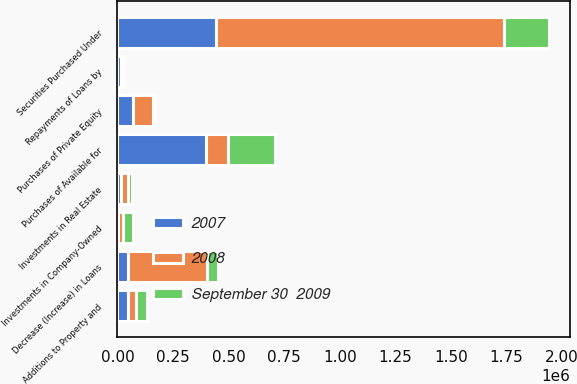Convert chart to OTSL. <chart><loc_0><loc_0><loc_500><loc_500><stacked_bar_chart><ecel><fcel>Additions to Property and<fcel>Decrease (Increase) in Loans<fcel>Purchases of Private Equity<fcel>Investments in Company-Owned<fcel>Investments in Real Estate<fcel>Repayments of Loans by<fcel>Securities Purchased Under<fcel>Purchases of Available for<nl><fcel>2008<fcel>35539<fcel>357054<fcel>88780<fcel>22793<fcel>30425<fcel>1829<fcel>1.295e+06<fcel>102516<nl><fcel>September 30  2009<fcel>51043<fcel>46949.5<fcel>12249<fcel>47818<fcel>18567<fcel>7320<fcel>200000<fcel>209546<nl><fcel>2007<fcel>46081<fcel>46949.5<fcel>68788<fcel>1200<fcel>18078<fcel>16619<fcel>445000<fcel>396450<nl></chart> 